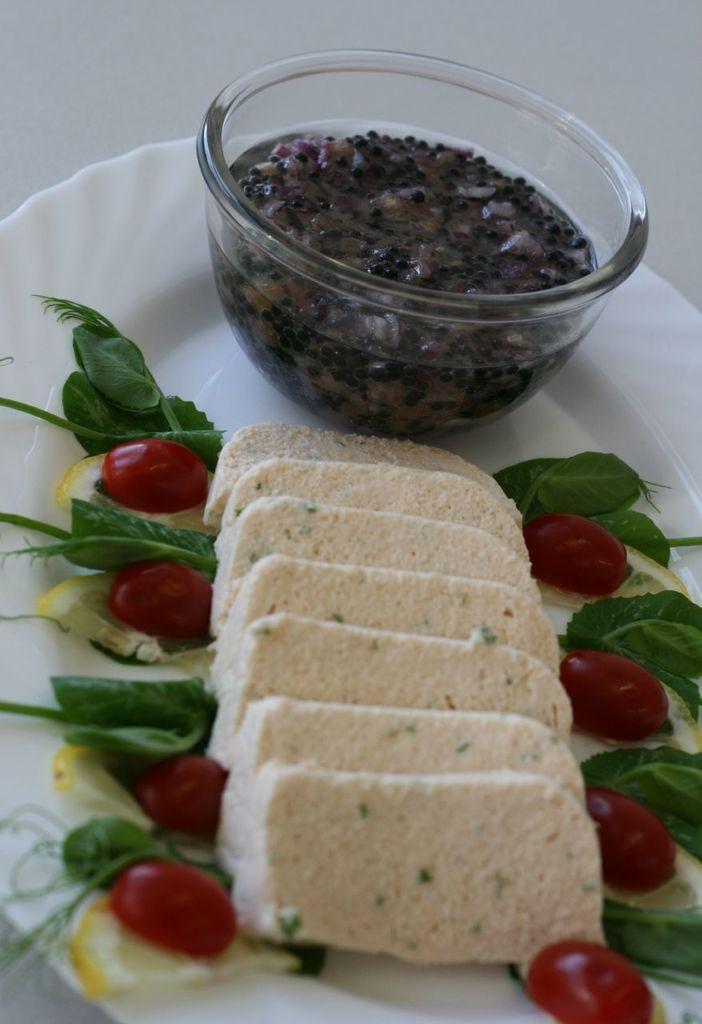Describe this image in one or two sentences. In this image we can see a serving plate which consists of bread slices, lemon wedges, cherry tomatoes, mint leaves, dill leaves and a bowl of dip in it. 